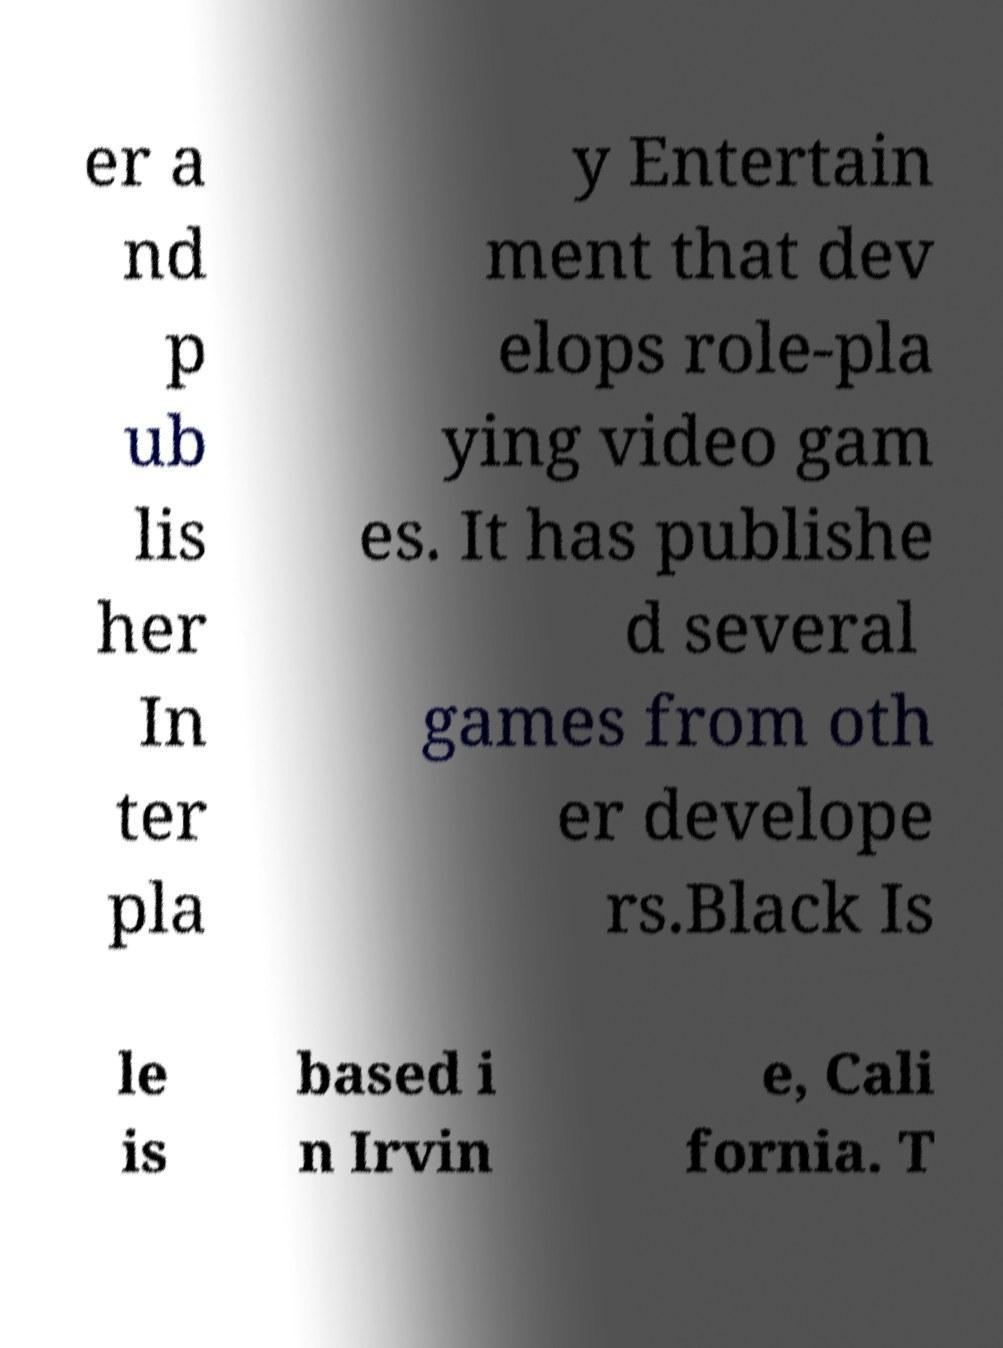What messages or text are displayed in this image? I need them in a readable, typed format. er a nd p ub lis her In ter pla y Entertain ment that dev elops role-pla ying video gam es. It has publishe d several games from oth er develope rs.Black Is le is based i n Irvin e, Cali fornia. T 